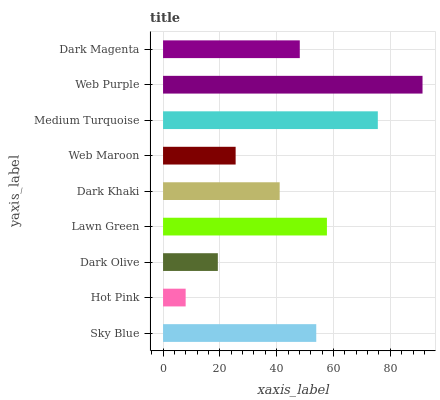Is Hot Pink the minimum?
Answer yes or no. Yes. Is Web Purple the maximum?
Answer yes or no. Yes. Is Dark Olive the minimum?
Answer yes or no. No. Is Dark Olive the maximum?
Answer yes or no. No. Is Dark Olive greater than Hot Pink?
Answer yes or no. Yes. Is Hot Pink less than Dark Olive?
Answer yes or no. Yes. Is Hot Pink greater than Dark Olive?
Answer yes or no. No. Is Dark Olive less than Hot Pink?
Answer yes or no. No. Is Dark Magenta the high median?
Answer yes or no. Yes. Is Dark Magenta the low median?
Answer yes or no. Yes. Is Hot Pink the high median?
Answer yes or no. No. Is Web Purple the low median?
Answer yes or no. No. 